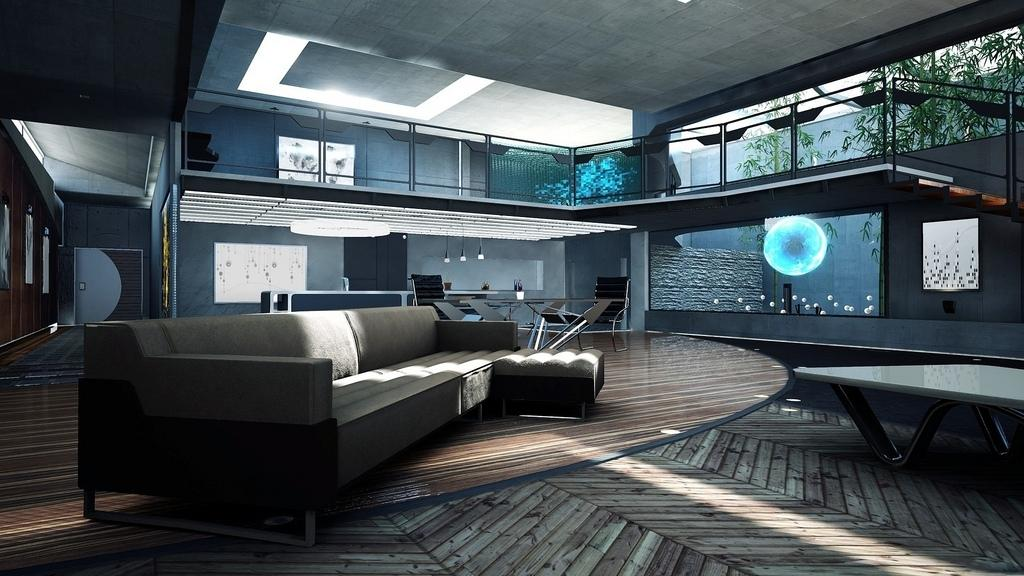What type of flooring is present in the room? The room has a wooden floor. What type of seating is available in the room? There is a sofa and a table with chairs arrangement in the room. How can one enter the room? There is a door in the room used to enter the room. What can be seen from the room? Trees are visible from the room. What type of corn is growing in the room? There is no corn growing in the room; the room has a wooden floor, a sofa, a table with chairs arrangement, a door, and trees are visible from the room. 